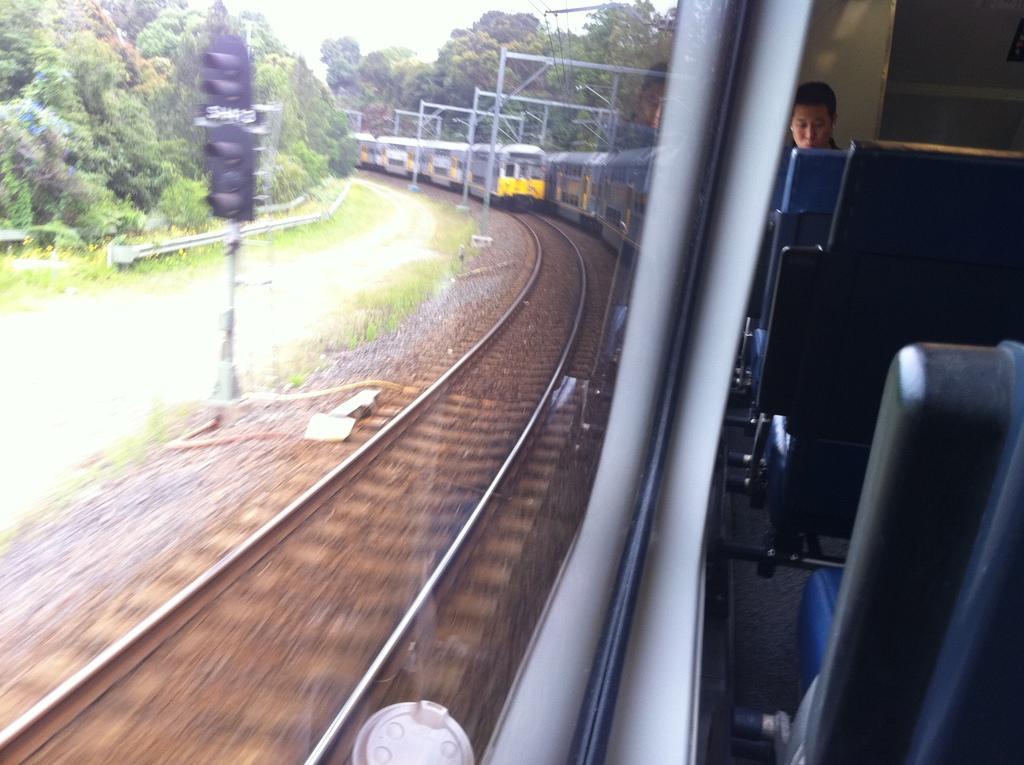How would you summarize this image in a sentence or two? The image is captured from inside a train, there are two trains moving on the tracks. On the left side there is a signal pole and beside that pole there are a lot of trees on the either side of the railway track. Inside the train there are many seats left empty and there is a person sitting in the last seat. 